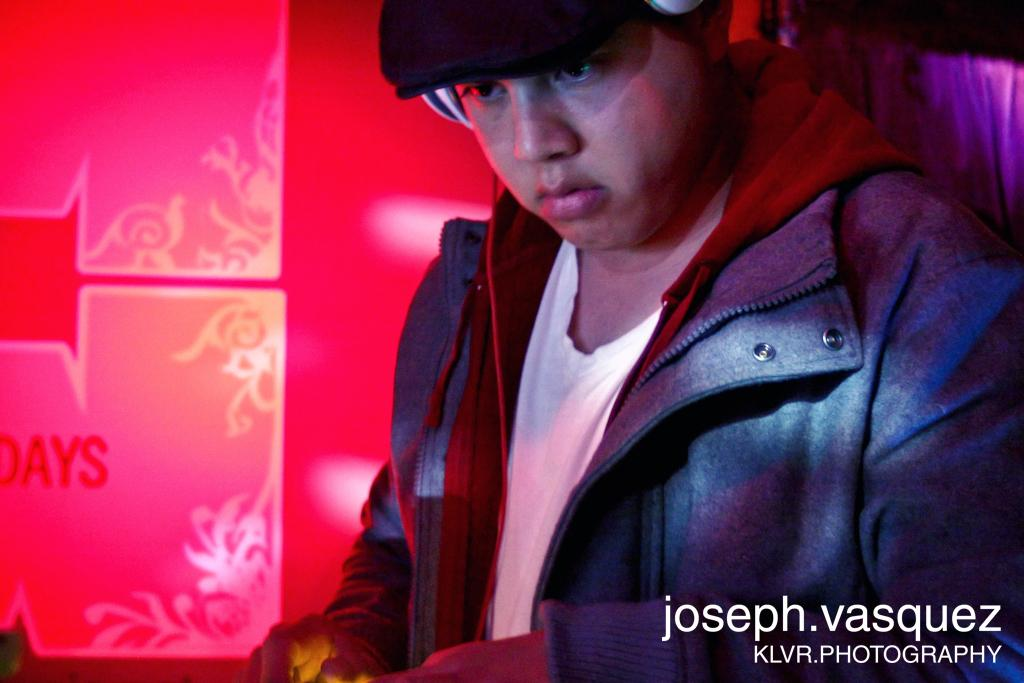Who is present in the image? There is a man in the image. What is the man wearing on his head? The man is wearing a headset and a cap. Are there any visible marks or features at the bottom right of the image? Yes, there are watermarks at the right bottom of the image. What type of town is depicted in the image? There is no town present in the image; it features a man wearing a headset and cap with watermarks at the bottom right. What form does the roof of the building in the image take? There is no building or roof present in the image. 